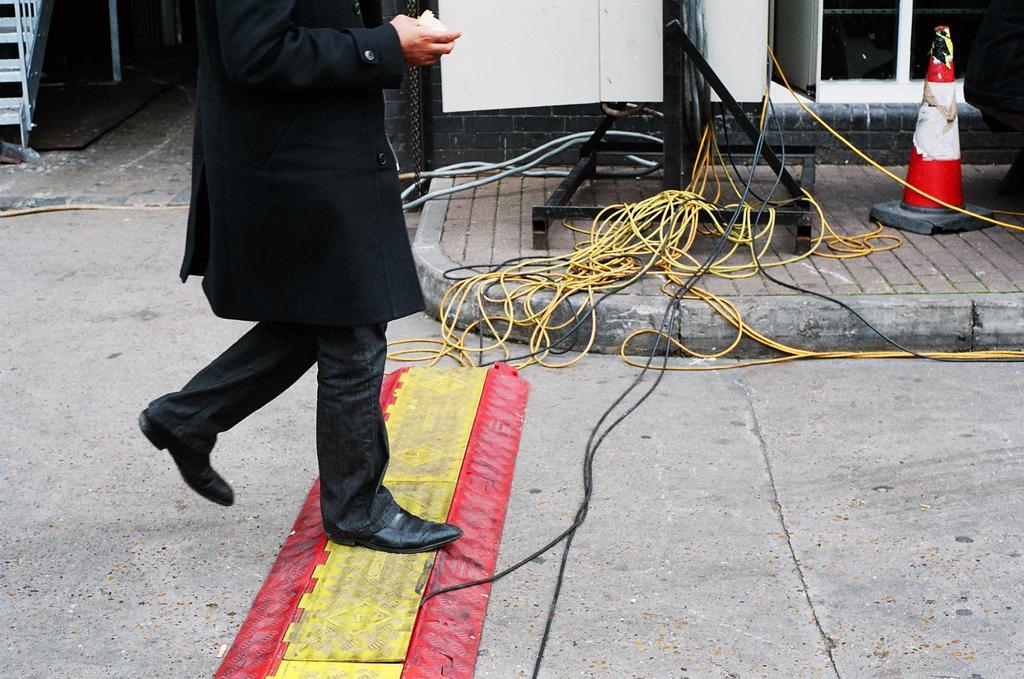In one or two sentences, can you explain what this image depicts? In this picture we can see a person is walking, there are some wires in the middle, on the right side there is a traffic cone, on the left side we can see stairs. 